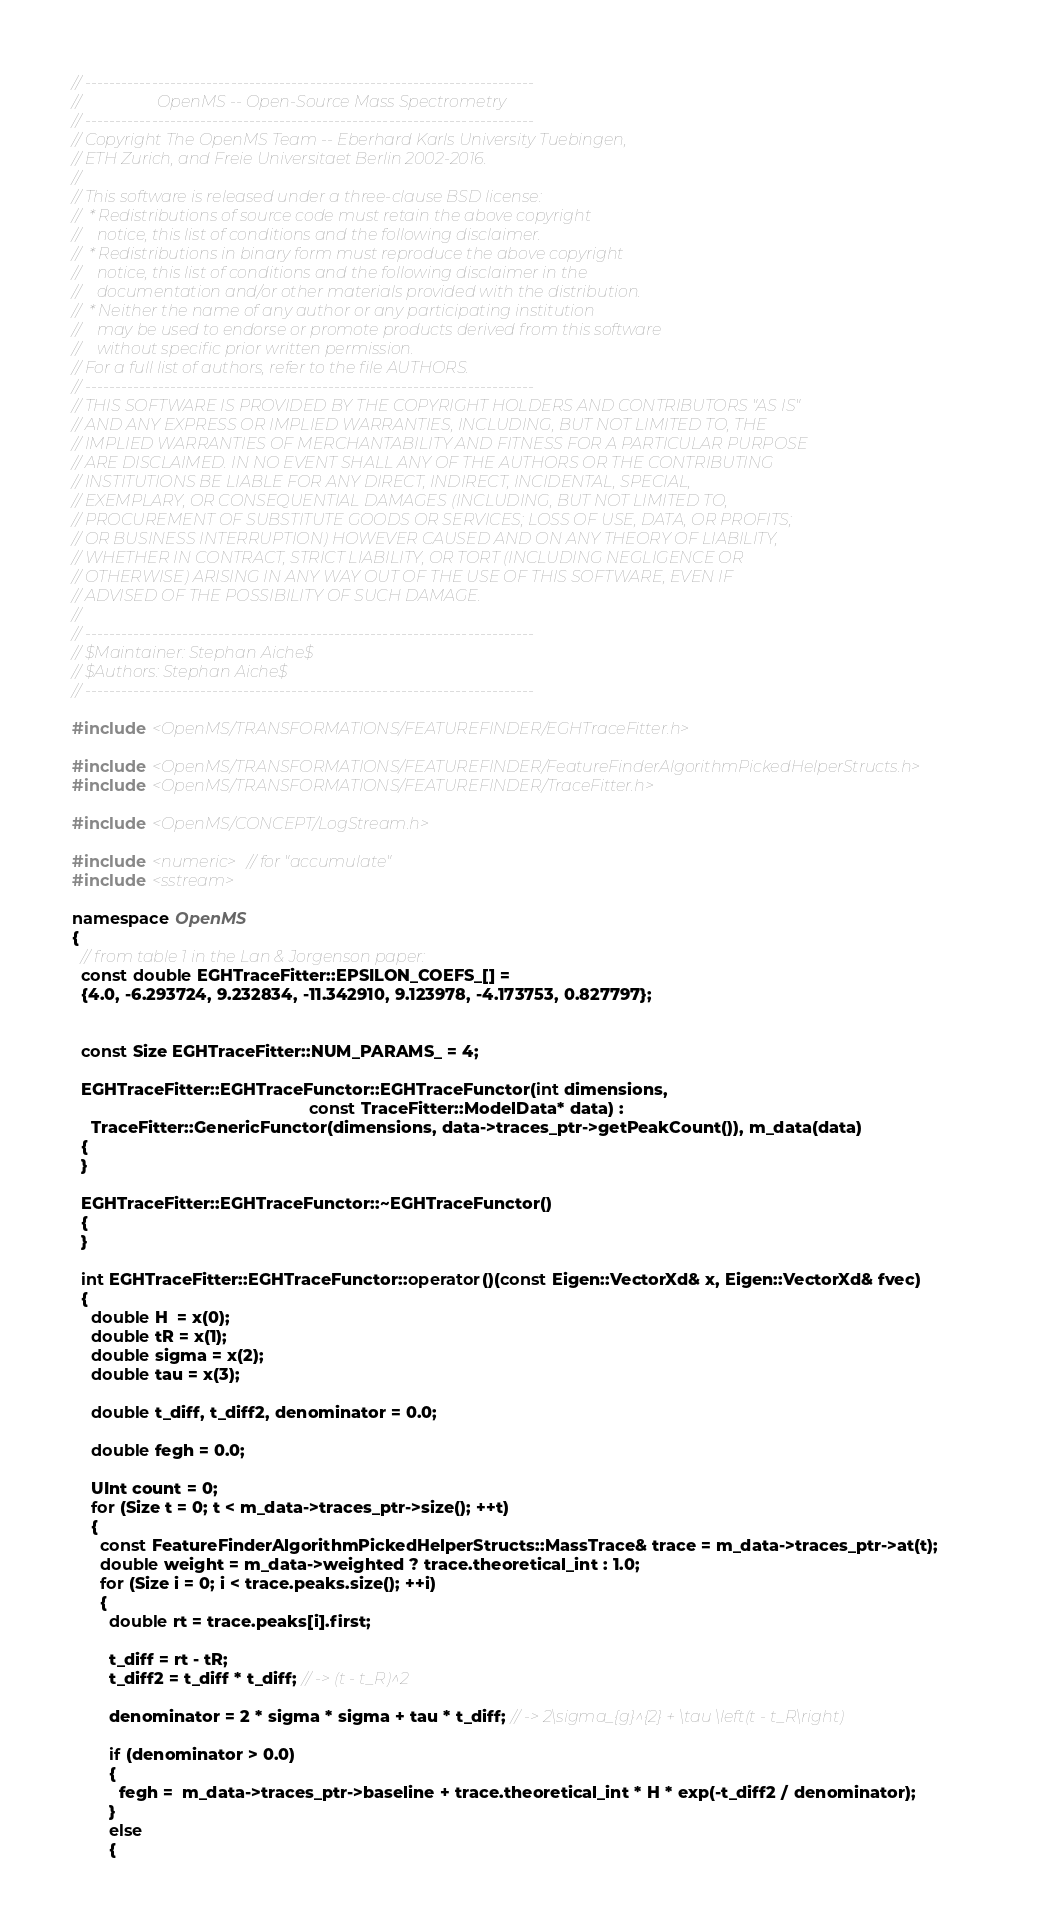<code> <loc_0><loc_0><loc_500><loc_500><_C++_>// --------------------------------------------------------------------------
//                   OpenMS -- Open-Source Mass Spectrometry
// --------------------------------------------------------------------------
// Copyright The OpenMS Team -- Eberhard Karls University Tuebingen,
// ETH Zurich, and Freie Universitaet Berlin 2002-2016.
//
// This software is released under a three-clause BSD license:
//  * Redistributions of source code must retain the above copyright
//    notice, this list of conditions and the following disclaimer.
//  * Redistributions in binary form must reproduce the above copyright
//    notice, this list of conditions and the following disclaimer in the
//    documentation and/or other materials provided with the distribution.
//  * Neither the name of any author or any participating institution
//    may be used to endorse or promote products derived from this software
//    without specific prior written permission.
// For a full list of authors, refer to the file AUTHORS.
// --------------------------------------------------------------------------
// THIS SOFTWARE IS PROVIDED BY THE COPYRIGHT HOLDERS AND CONTRIBUTORS "AS IS"
// AND ANY EXPRESS OR IMPLIED WARRANTIES, INCLUDING, BUT NOT LIMITED TO, THE
// IMPLIED WARRANTIES OF MERCHANTABILITY AND FITNESS FOR A PARTICULAR PURPOSE
// ARE DISCLAIMED. IN NO EVENT SHALL ANY OF THE AUTHORS OR THE CONTRIBUTING
// INSTITUTIONS BE LIABLE FOR ANY DIRECT, INDIRECT, INCIDENTAL, SPECIAL,
// EXEMPLARY, OR CONSEQUENTIAL DAMAGES (INCLUDING, BUT NOT LIMITED TO,
// PROCUREMENT OF SUBSTITUTE GOODS OR SERVICES; LOSS OF USE, DATA, OR PROFITS;
// OR BUSINESS INTERRUPTION) HOWEVER CAUSED AND ON ANY THEORY OF LIABILITY,
// WHETHER IN CONTRACT, STRICT LIABILITY, OR TORT (INCLUDING NEGLIGENCE OR
// OTHERWISE) ARISING IN ANY WAY OUT OF THE USE OF THIS SOFTWARE, EVEN IF
// ADVISED OF THE POSSIBILITY OF SUCH DAMAGE.
//
// --------------------------------------------------------------------------
// $Maintainer: Stephan Aiche$
// $Authors: Stephan Aiche$
// --------------------------------------------------------------------------

#include <OpenMS/TRANSFORMATIONS/FEATUREFINDER/EGHTraceFitter.h>

#include <OpenMS/TRANSFORMATIONS/FEATUREFINDER/FeatureFinderAlgorithmPickedHelperStructs.h>
#include <OpenMS/TRANSFORMATIONS/FEATUREFINDER/TraceFitter.h>

#include <OpenMS/CONCEPT/LogStream.h>

#include <numeric> // for "accumulate"
#include <sstream>

namespace OpenMS
{
  // from table 1 in the Lan & Jorgenson paper:
  const double EGHTraceFitter::EPSILON_COEFS_[] =
  {4.0, -6.293724, 9.232834, -11.342910, 9.123978, -4.173753, 0.827797};


  const Size EGHTraceFitter::NUM_PARAMS_ = 4;

  EGHTraceFitter::EGHTraceFunctor::EGHTraceFunctor(int dimensions,
                                                   const TraceFitter::ModelData* data) :
    TraceFitter::GenericFunctor(dimensions, data->traces_ptr->getPeakCount()), m_data(data)
  {
  }

  EGHTraceFitter::EGHTraceFunctor::~EGHTraceFunctor()
  {
  }

  int EGHTraceFitter::EGHTraceFunctor::operator()(const Eigen::VectorXd& x, Eigen::VectorXd& fvec)
  {
    double H  = x(0);
    double tR = x(1);
    double sigma = x(2);
    double tau = x(3);

    double t_diff, t_diff2, denominator = 0.0;

    double fegh = 0.0;

    UInt count = 0;
    for (Size t = 0; t < m_data->traces_ptr->size(); ++t)
    {
      const FeatureFinderAlgorithmPickedHelperStructs::MassTrace& trace = m_data->traces_ptr->at(t);
      double weight = m_data->weighted ? trace.theoretical_int : 1.0;
      for (Size i = 0; i < trace.peaks.size(); ++i)
      {
        double rt = trace.peaks[i].first;

        t_diff = rt - tR;
        t_diff2 = t_diff * t_diff; // -> (t - t_R)^2

        denominator = 2 * sigma * sigma + tau * t_diff; // -> 2\sigma_{g}^{2} + \tau \left(t - t_R\right)

        if (denominator > 0.0)
        {
          fegh =  m_data->traces_ptr->baseline + trace.theoretical_int * H * exp(-t_diff2 / denominator);
        }
        else
        {</code> 